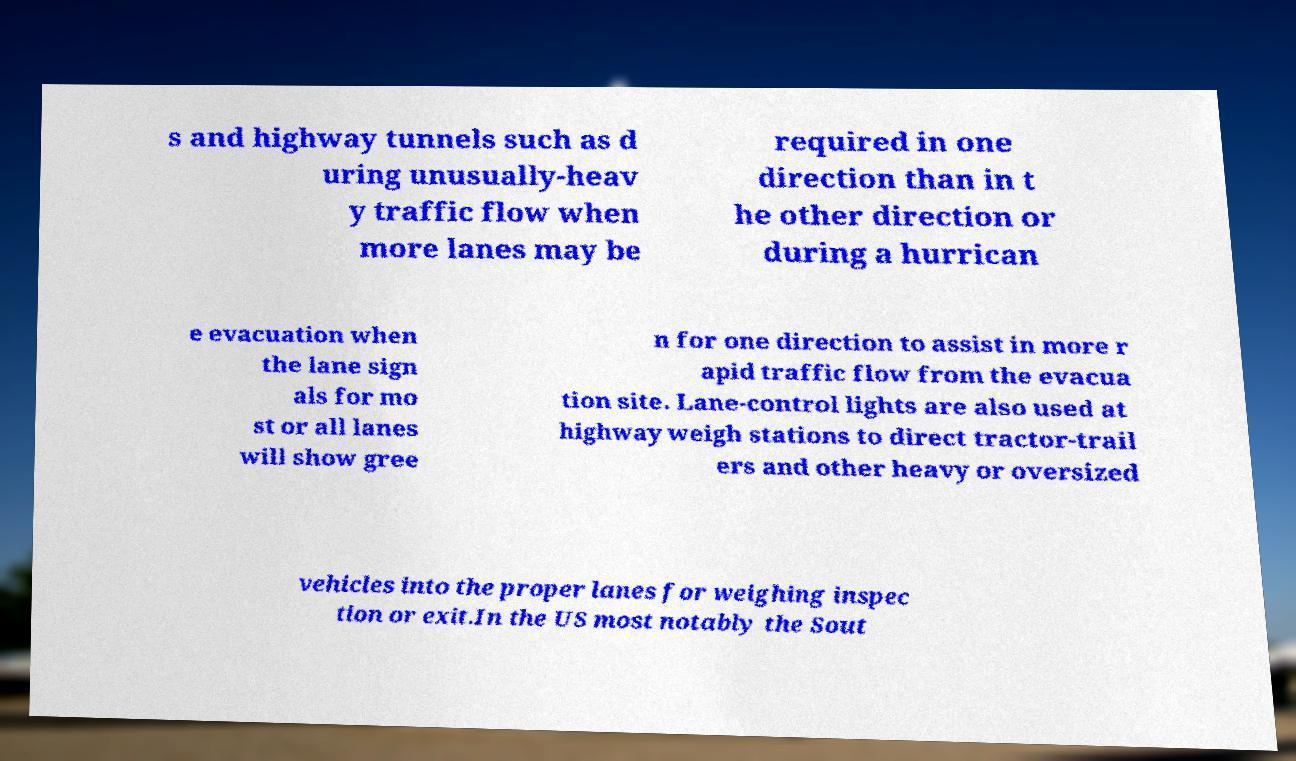For documentation purposes, I need the text within this image transcribed. Could you provide that? s and highway tunnels such as d uring unusually-heav y traffic flow when more lanes may be required in one direction than in t he other direction or during a hurrican e evacuation when the lane sign als for mo st or all lanes will show gree n for one direction to assist in more r apid traffic flow from the evacua tion site. Lane-control lights are also used at highway weigh stations to direct tractor-trail ers and other heavy or oversized vehicles into the proper lanes for weighing inspec tion or exit.In the US most notably the Sout 